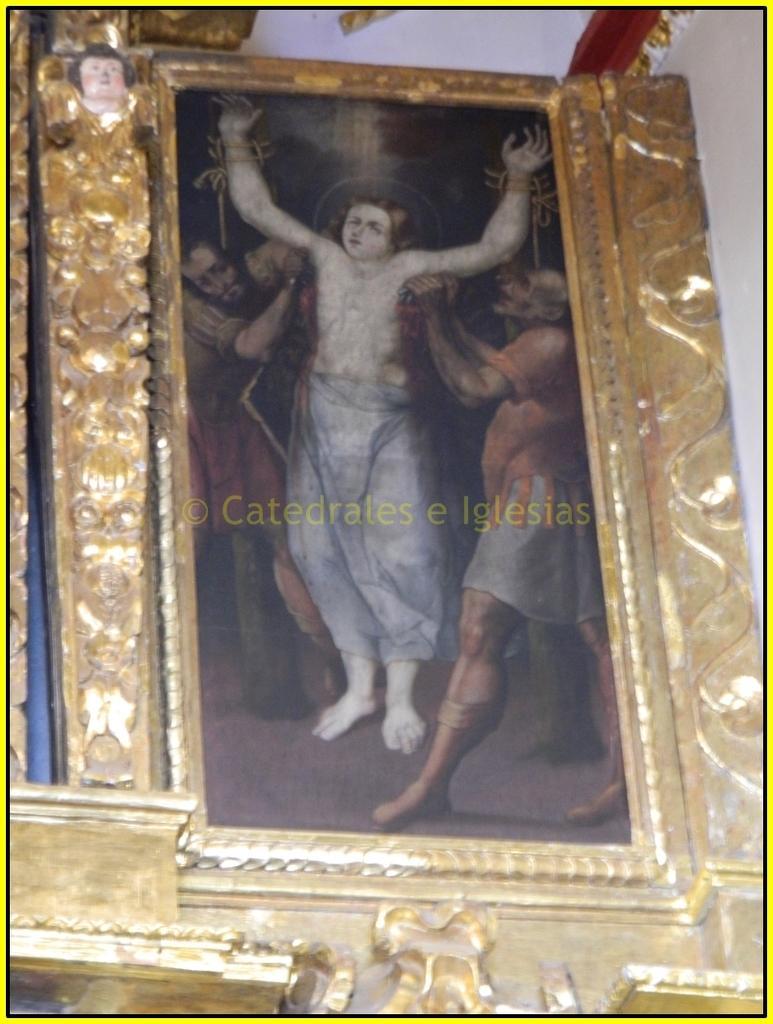In one or two sentences, can you explain what this image depicts? In this image we can see the photo frame covered with golden frame. Here we can see the watermark on the center of the image. 